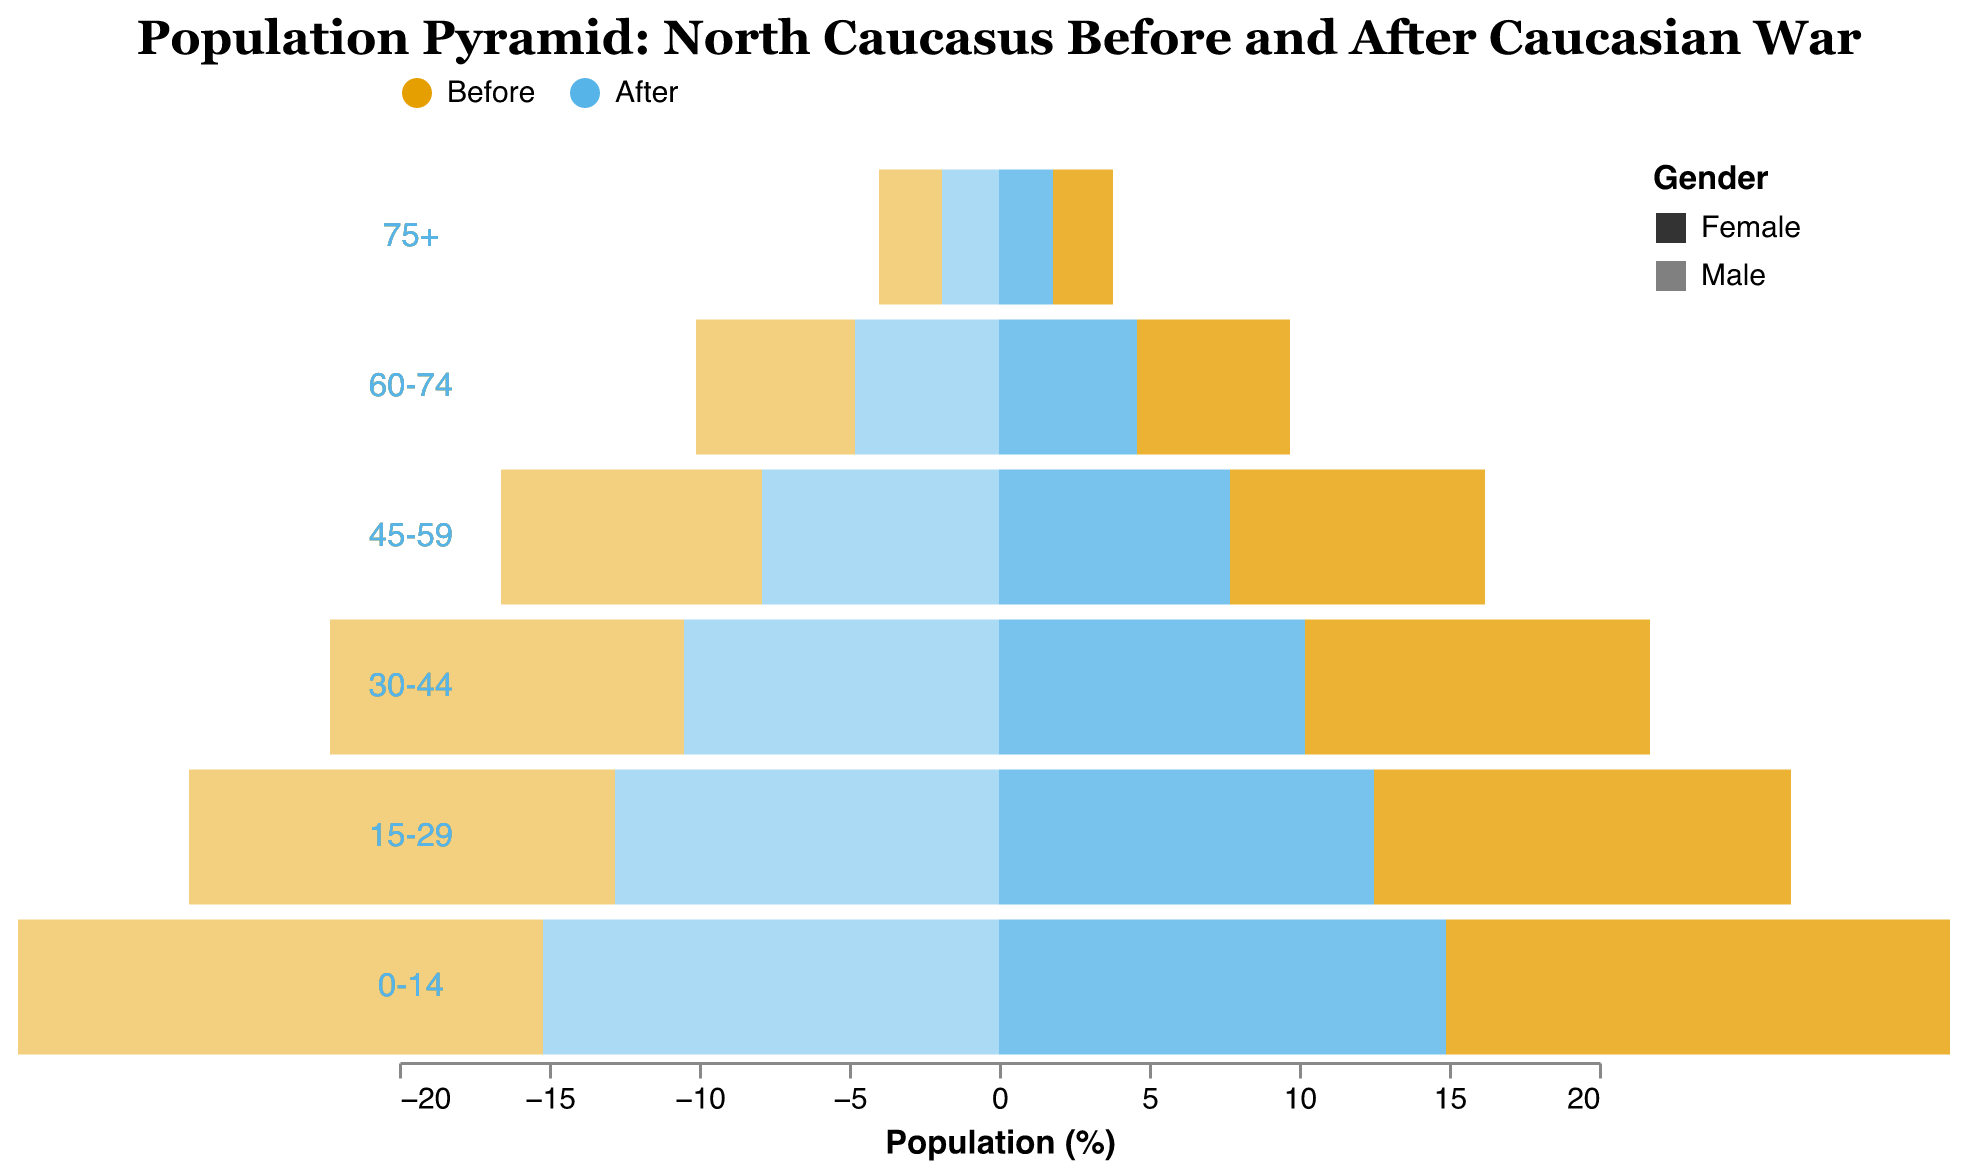What is the title of the figure? The title is provided at the top of the figure to describe its content. The title is "Population Pyramid: North Caucasus Before and After Caucasian War."
Answer: Population Pyramid: North Caucasus Before and After Caucasian War Which age group had the highest male population percentage before the Caucasian War? To determine the highest male population percentage before the war, we look at the 'Male Before' column and find the age group with the largest value. The "0-14" age group has 17.5%.
Answer: 0-14 What is the difference between the male population percentages in the "15-29" age group before and after the Caucasian War? To find the difference, we subtract the "Male After" percentage from the "Male Before" percentage for the "15-29" age group. The difference is 14.2% - 12.8% = 1.4%.
Answer: 1.4% Comparing the "Female After" percentages, which age group has the lowest percentage and what is it? To find the lowest "Female After" population percentage, we look at the "Female After" column and identify the smallest value. The "75+" age group has 1.8%, which is the lowest.
Answer: 75+, 1.8% How does the percentage of females in the "60-74" age group before the Caucasian War compare to the percentage after? We compare the values for the "60-74" age group in the "Female Before" and "Female After" columns. The "Female Before" percentage is 5.1%, while the "Female After" percentage is 4.6%. Therefore, the "Female Before" percentage is higher.
Answer: Higher before the war What is the total population percentage for males and females before the war for the "45-59" age group? We add the "Male Before" and "Female Before" percentages for the "45-59" age group. The total is 8.7% + 8.5% = 17.2%.
Answer: 17.2% Which gender saw a greater decline in the "0-14" age group after the Caucasian War? To determine this, we calculate the decline for both genders by subtracting the "After" percentages from the "Before" percentages for the "0-14" age group. Males: 17.5% - 15.2% = 2.3%, Females: 16.8% - 14.9% = 1.9%. Males saw a greater decline.
Answer: Males Is there any age group where the percentage of females after the war is equal to the percentage of males after the war? We compare the "Female After" and "Male After" percentages for all age groups. No age group has equal percentages for males and females after the war.
Answer: No What is the average percentage decline in the population for the "30-44" age group after the war for both genders? To find the average percentage decline, we first find the decline for both "Male After" and "Female After" by subtracting the "After" percentages from the "Before" percentages: Males: 11.8% - 10.5% = 1.3%, Females: 11.5% - 10.2% = 1.3%. The average decline is (1.3% + 1.3%) / 2 = 1.3%.
Answer: 1.3% 